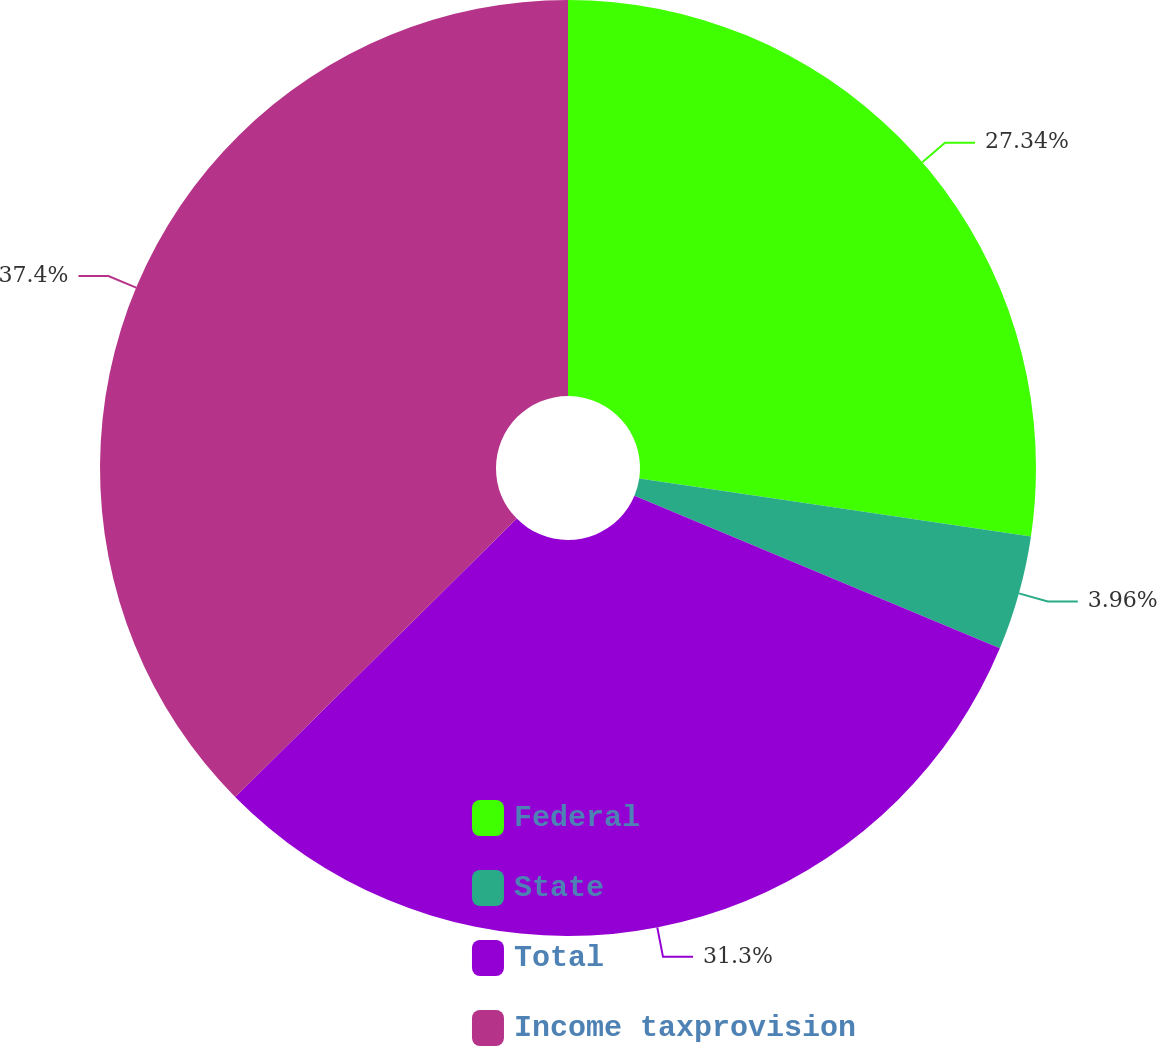Convert chart. <chart><loc_0><loc_0><loc_500><loc_500><pie_chart><fcel>Federal<fcel>State<fcel>Total<fcel>Income taxprovision<nl><fcel>27.34%<fcel>3.96%<fcel>31.3%<fcel>37.41%<nl></chart> 